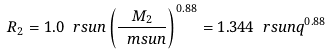<formula> <loc_0><loc_0><loc_500><loc_500>R _ { 2 } = 1 . 0 \ r s u n \left ( \frac { M _ { 2 } } { \ m s u n } \right ) ^ { 0 . 8 8 } = 1 . 3 4 4 \ r s u n q ^ { 0 . 8 8 }</formula> 